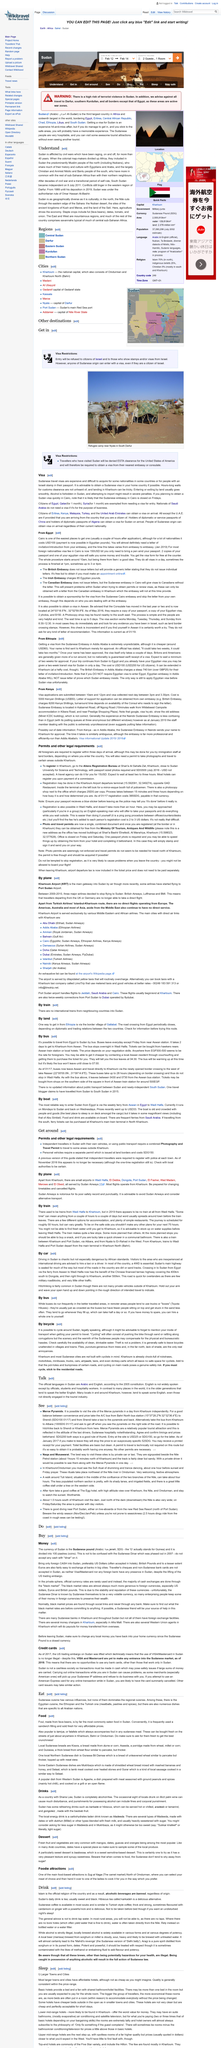Mention a couple of crucial points in this snapshot. If you have money to spare, it is advisable to hire an entire bus for yourself, as it enables you to travel in luxury and privacy. The travel from Egypt to Sudan can be done by bus. Basic hotels offer basic accommodations that typically include a bed and a fan, along with shared bathroom/toilet facilities. The currency of the Sudan is the Sudanese pound. Sudan, as a country with Sharia Law, is completely alcohol-free. 